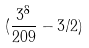Convert formula to latex. <formula><loc_0><loc_0><loc_500><loc_500>( \frac { 3 ^ { 8 } } { 2 0 9 } - 3 / 2 )</formula> 